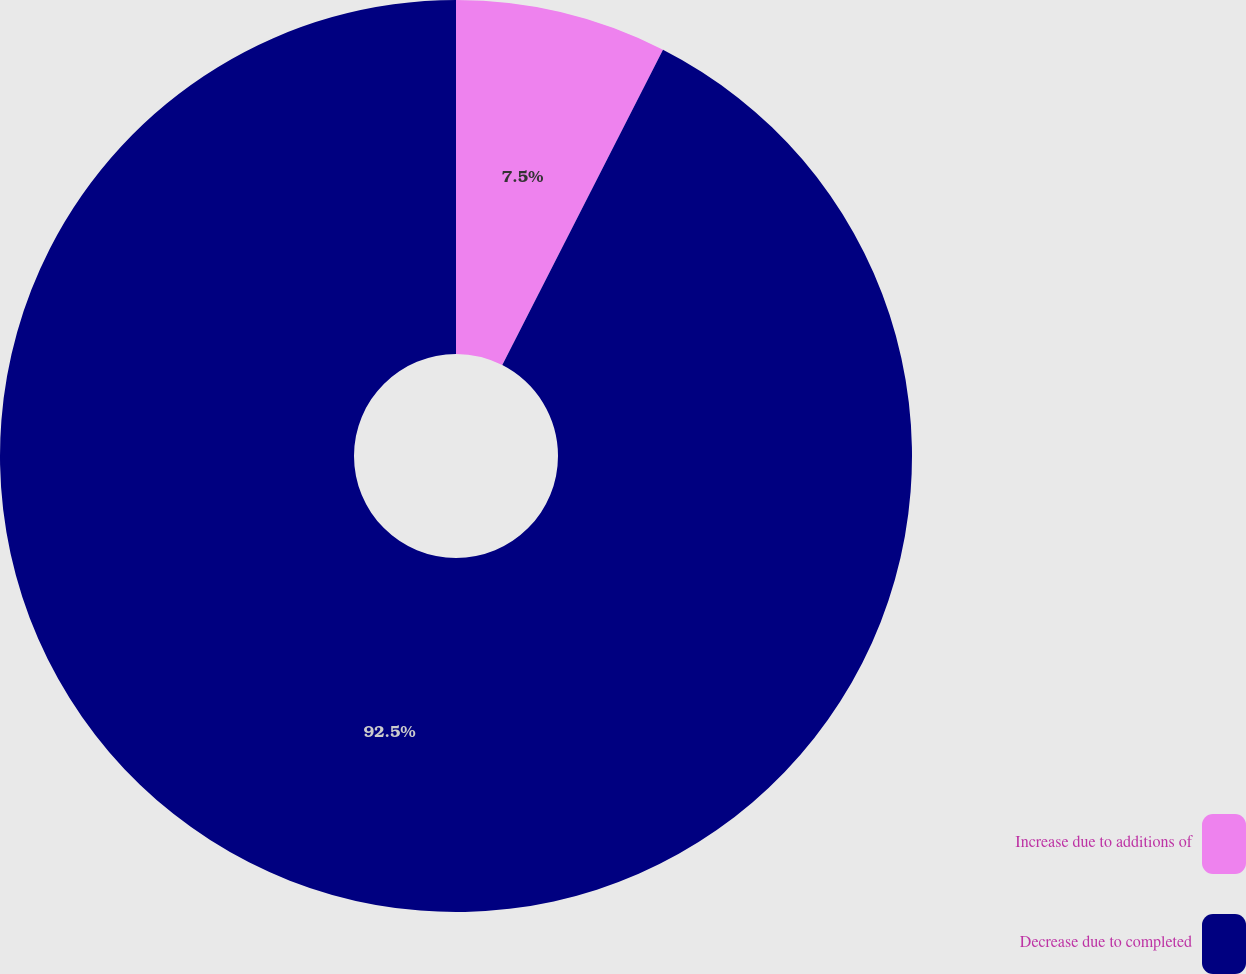Convert chart to OTSL. <chart><loc_0><loc_0><loc_500><loc_500><pie_chart><fcel>Increase due to additions of<fcel>Decrease due to completed<nl><fcel>7.5%<fcel>92.5%<nl></chart> 